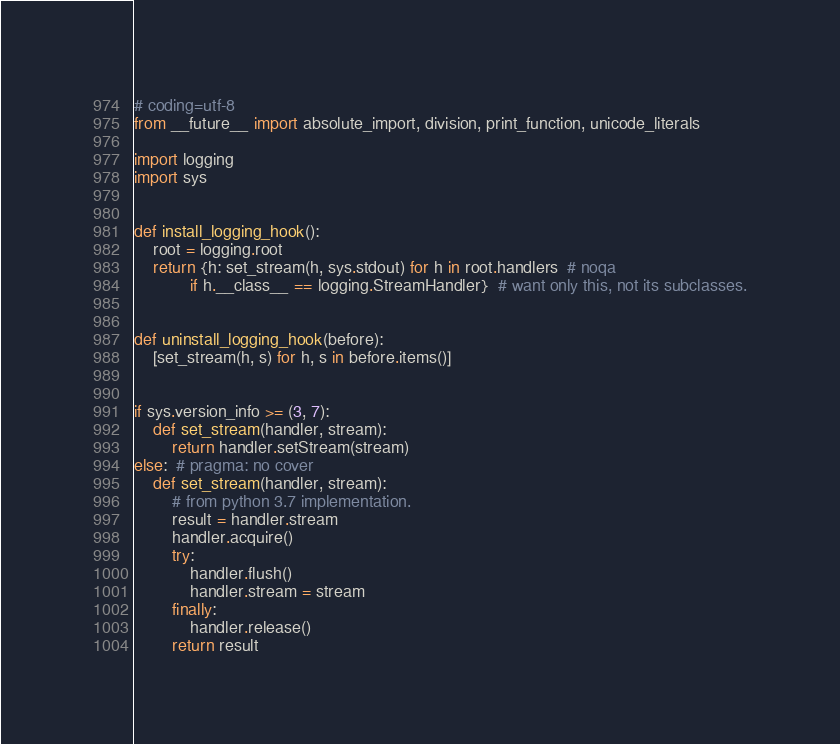<code> <loc_0><loc_0><loc_500><loc_500><_Python_># coding=utf-8
from __future__ import absolute_import, division, print_function, unicode_literals

import logging
import sys


def install_logging_hook():
    root = logging.root
    return {h: set_stream(h, sys.stdout) for h in root.handlers  # noqa
            if h.__class__ == logging.StreamHandler}  # want only this, not its subclasses.


def uninstall_logging_hook(before):
    [set_stream(h, s) for h, s in before.items()]


if sys.version_info >= (3, 7):
    def set_stream(handler, stream):
        return handler.setStream(stream)
else:  # pragma: no cover
    def set_stream(handler, stream):
        # from python 3.7 implementation.
        result = handler.stream
        handler.acquire()
        try:
            handler.flush()
            handler.stream = stream
        finally:
            handler.release()
        return result
</code> 